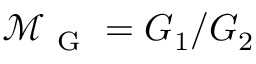<formula> <loc_0><loc_0><loc_500><loc_500>\mathcal { M } _ { G } = G _ { 1 } / G _ { 2 }</formula> 